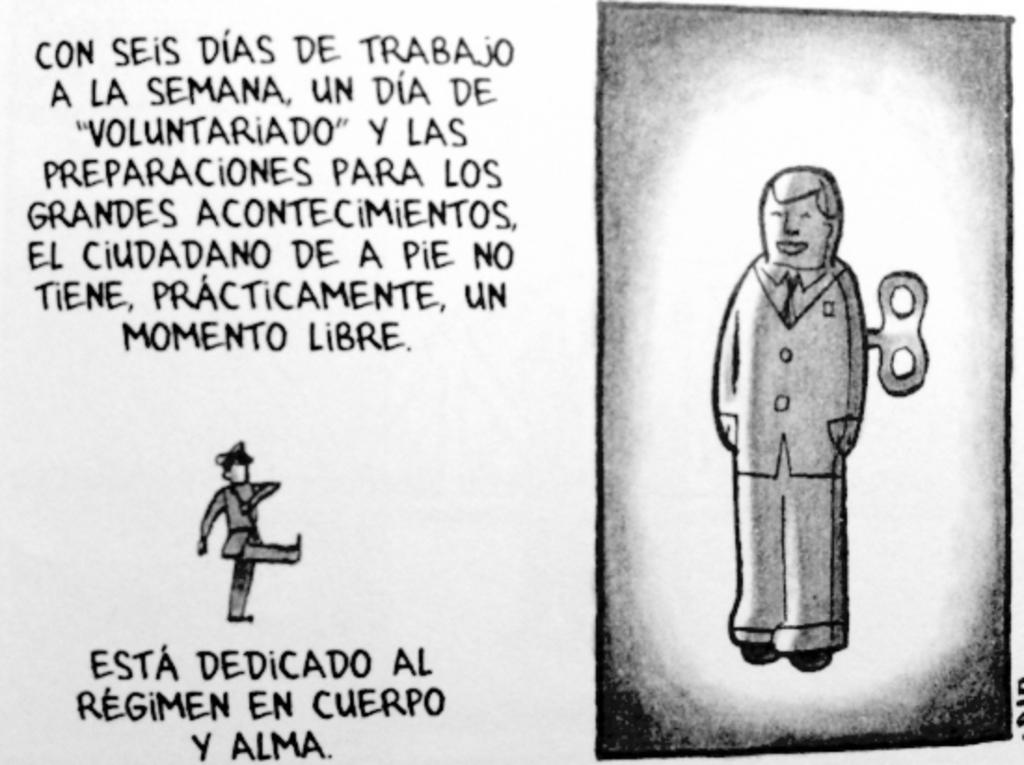What type of characters are present in the image? There are two cartoons in the image. How were the cartoons created? The cartoons are drawn. What can be seen in addition to the cartoons in the image? There is text written with black ink in the image. What type of collar is visible on the cartoon character in the image? There is no collar present on the cartoon characters in the image, as they are drawn and not depicted as wearing clothing. 